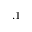<formula> <loc_0><loc_0><loc_500><loc_500>. 1</formula> 